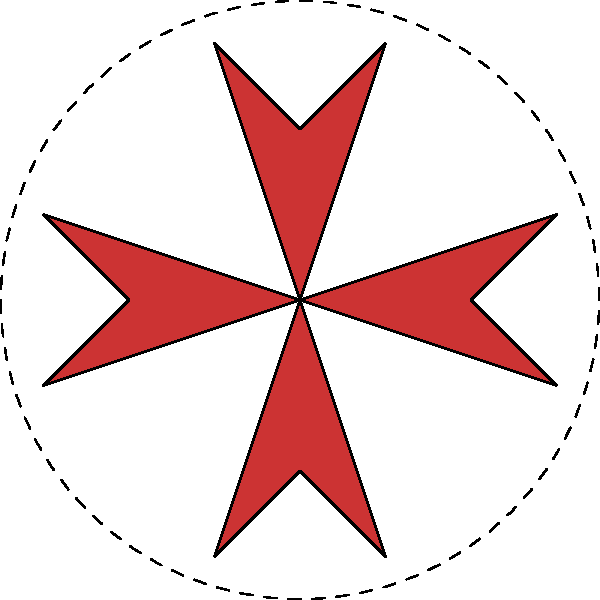Bright's stylist has created a symmetrical pattern inspired by his fashion style, as shown in the diagram. The pattern consists of four identical star shapes arranged around a central point. What combination of transformations would you use to create this pattern from a single star shape, and what type of symmetry does the final pattern exhibit? To create this pattern from a single star shape, we need to follow these steps:

1. Start with the original star shape in one quadrant.

2. Apply a series of rotations around the central point:
   a) Rotate 90° clockwise to create the second star
   b) Rotate 180° from the original position to create the third star
   c) Rotate 270° clockwise (or 90° counterclockwise) from the original position to create the fourth star

3. This combination of rotations creates a pattern with rotational symmetry.

4. The resulting pattern also exhibits reflectional symmetry across two perpendicular lines passing through the center (horizontal and vertical axes).

5. The overall symmetry type of this pattern is called "4-fold rotational symmetry" because it can be rotated by 90°, 180°, 270°, or 360° and still look the same.

6. Additionally, the pattern has "dihedral symmetry" due to its combination of rotational and reflectional symmetries.
Answer: 90°, 180°, and 270° rotations; 4-fold rotational symmetry and dihedral symmetry 